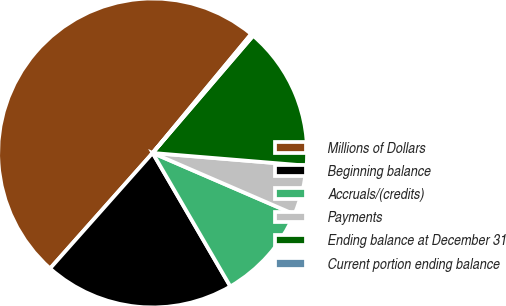Convert chart to OTSL. <chart><loc_0><loc_0><loc_500><loc_500><pie_chart><fcel>Millions of Dollars<fcel>Beginning balance<fcel>Accruals/(credits)<fcel>Payments<fcel>Ending balance at December 31<fcel>Current portion ending balance<nl><fcel>49.46%<fcel>19.95%<fcel>10.11%<fcel>5.19%<fcel>15.03%<fcel>0.27%<nl></chart> 